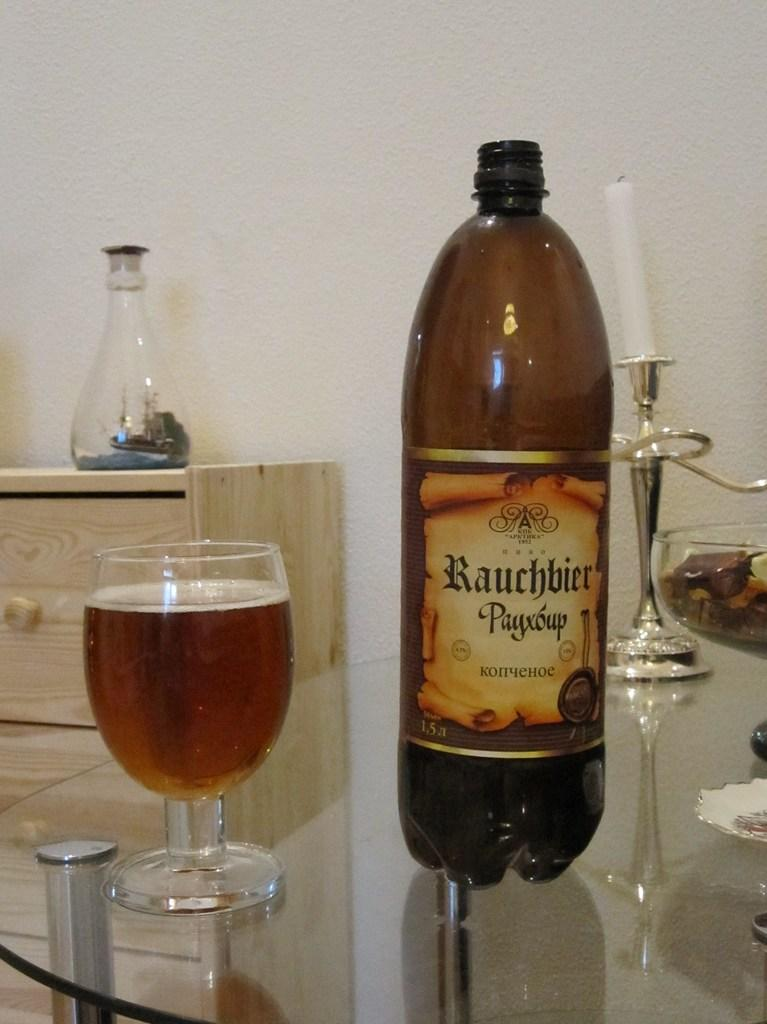What is one of the objects visible in the image? There is a bottle in the image. What is another object visible in the image? There is a glass in the image. What is the third object visible in the image? There is a candle in the image. Can you describe any other objects in the image? There are additional unspecified objects in the image. What type of oil is being used to fuel the candle in the image? There is no oil present in the image, and the candle is not being fueled by any oil. 